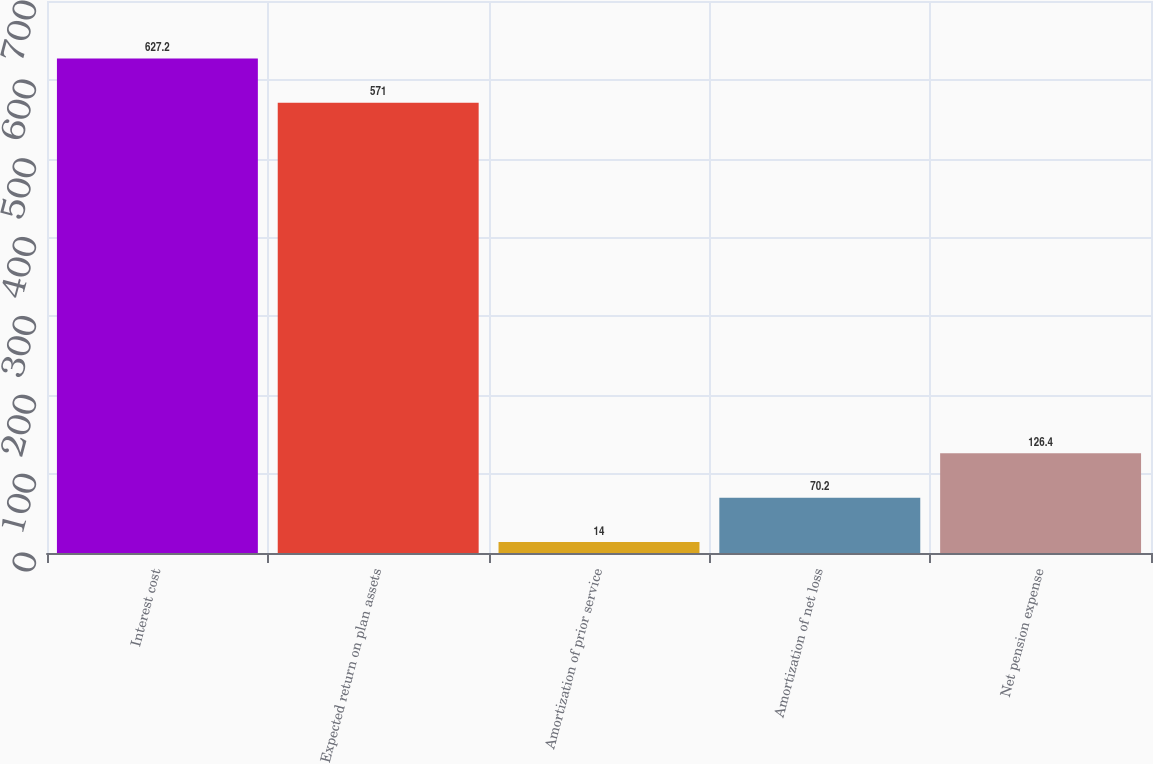<chart> <loc_0><loc_0><loc_500><loc_500><bar_chart><fcel>Interest cost<fcel>Expected return on plan assets<fcel>Amortization of prior service<fcel>Amortization of net loss<fcel>Net pension expense<nl><fcel>627.2<fcel>571<fcel>14<fcel>70.2<fcel>126.4<nl></chart> 